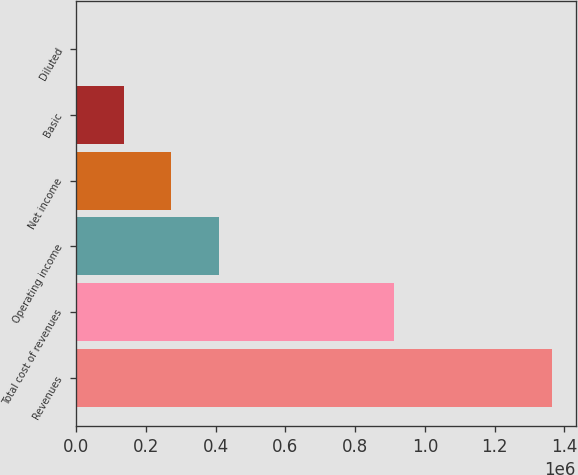Convert chart to OTSL. <chart><loc_0><loc_0><loc_500><loc_500><bar_chart><fcel>Revenues<fcel>Total cost of revenues<fcel>Operating income<fcel>Net income<fcel>Basic<fcel>Diluted<nl><fcel>1.36466e+06<fcel>910234<fcel>409399<fcel>272933<fcel>136467<fcel>1.32<nl></chart> 